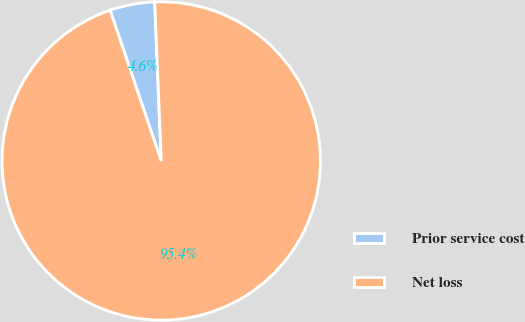<chart> <loc_0><loc_0><loc_500><loc_500><pie_chart><fcel>Prior service cost<fcel>Net loss<nl><fcel>4.55%<fcel>95.45%<nl></chart> 